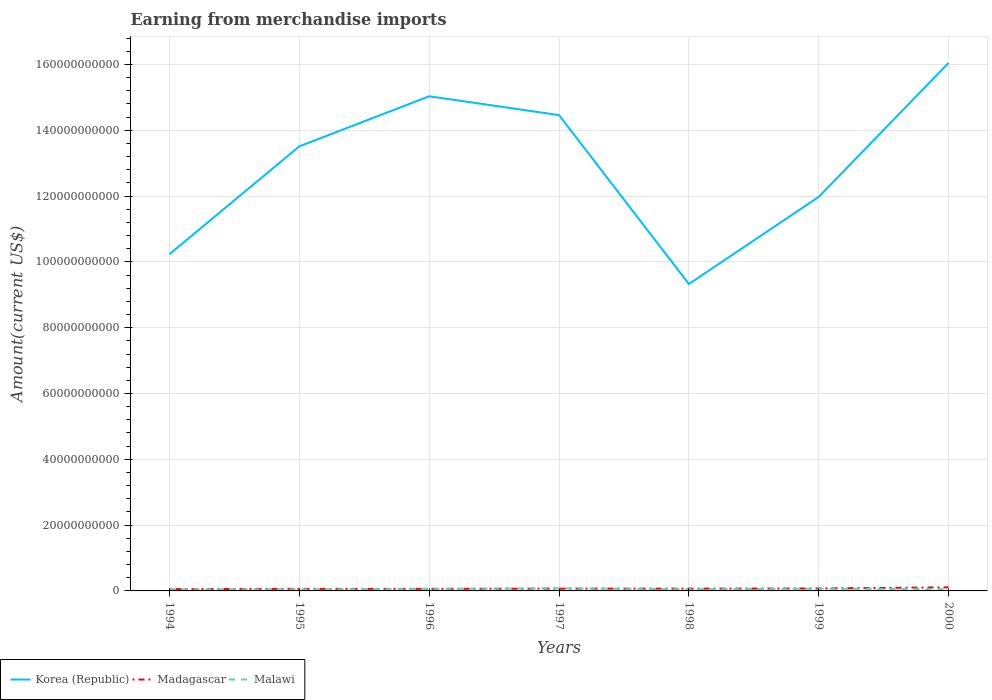How many different coloured lines are there?
Your answer should be very brief. 3. Is the number of lines equal to the number of legend labels?
Provide a short and direct response. Yes. Across all years, what is the maximum amount earned from merchandise imports in Madagascar?
Offer a terse response. 5.46e+08. What is the total amount earned from merchandise imports in Madagascar in the graph?
Offer a very short reply. -1.00e+06. What is the difference between the highest and the second highest amount earned from merchandise imports in Madagascar?
Make the answer very short. 5.51e+08. What is the difference between the highest and the lowest amount earned from merchandise imports in Madagascar?
Make the answer very short. 2. Is the amount earned from merchandise imports in Madagascar strictly greater than the amount earned from merchandise imports in Malawi over the years?
Your answer should be compact. No. How many lines are there?
Your response must be concise. 3. Are the values on the major ticks of Y-axis written in scientific E-notation?
Your answer should be compact. No. Does the graph contain any zero values?
Offer a very short reply. No. What is the title of the graph?
Make the answer very short. Earning from merchandise imports. What is the label or title of the X-axis?
Your answer should be compact. Years. What is the label or title of the Y-axis?
Give a very brief answer. Amount(current US$). What is the Amount(current US$) of Korea (Republic) in 1994?
Ensure brevity in your answer.  1.02e+11. What is the Amount(current US$) in Madagascar in 1994?
Make the answer very short. 5.46e+08. What is the Amount(current US$) of Malawi in 1994?
Your answer should be very brief. 4.97e+08. What is the Amount(current US$) of Korea (Republic) in 1995?
Offer a terse response. 1.35e+11. What is the Amount(current US$) in Madagascar in 1995?
Offer a terse response. 6.28e+08. What is the Amount(current US$) in Malawi in 1995?
Ensure brevity in your answer.  4.75e+08. What is the Amount(current US$) of Korea (Republic) in 1996?
Make the answer very short. 1.50e+11. What is the Amount(current US$) of Madagascar in 1996?
Offer a terse response. 6.29e+08. What is the Amount(current US$) of Malawi in 1996?
Your response must be concise. 6.24e+08. What is the Amount(current US$) of Korea (Republic) in 1997?
Offer a very short reply. 1.45e+11. What is the Amount(current US$) in Madagascar in 1997?
Offer a terse response. 6.94e+08. What is the Amount(current US$) of Malawi in 1997?
Keep it short and to the point. 7.81e+08. What is the Amount(current US$) of Korea (Republic) in 1998?
Your response must be concise. 9.33e+1. What is the Amount(current US$) in Madagascar in 1998?
Provide a succinct answer. 6.93e+08. What is the Amount(current US$) of Malawi in 1998?
Your response must be concise. 5.15e+08. What is the Amount(current US$) of Korea (Republic) in 1999?
Offer a terse response. 1.20e+11. What is the Amount(current US$) in Madagascar in 1999?
Your answer should be compact. 7.42e+08. What is the Amount(current US$) in Malawi in 1999?
Your answer should be very brief. 6.73e+08. What is the Amount(current US$) in Korea (Republic) in 2000?
Make the answer very short. 1.60e+11. What is the Amount(current US$) of Madagascar in 2000?
Your response must be concise. 1.10e+09. What is the Amount(current US$) in Malawi in 2000?
Offer a very short reply. 5.32e+08. Across all years, what is the maximum Amount(current US$) in Korea (Republic)?
Provide a succinct answer. 1.60e+11. Across all years, what is the maximum Amount(current US$) of Madagascar?
Provide a short and direct response. 1.10e+09. Across all years, what is the maximum Amount(current US$) of Malawi?
Make the answer very short. 7.81e+08. Across all years, what is the minimum Amount(current US$) of Korea (Republic)?
Offer a terse response. 9.33e+1. Across all years, what is the minimum Amount(current US$) of Madagascar?
Make the answer very short. 5.46e+08. Across all years, what is the minimum Amount(current US$) of Malawi?
Offer a very short reply. 4.75e+08. What is the total Amount(current US$) in Korea (Republic) in the graph?
Keep it short and to the point. 9.06e+11. What is the total Amount(current US$) in Madagascar in the graph?
Make the answer very short. 5.03e+09. What is the total Amount(current US$) in Malawi in the graph?
Your answer should be compact. 4.10e+09. What is the difference between the Amount(current US$) in Korea (Republic) in 1994 and that in 1995?
Offer a terse response. -3.28e+1. What is the difference between the Amount(current US$) in Madagascar in 1994 and that in 1995?
Provide a succinct answer. -8.20e+07. What is the difference between the Amount(current US$) in Malawi in 1994 and that in 1995?
Offer a terse response. 2.20e+07. What is the difference between the Amount(current US$) of Korea (Republic) in 1994 and that in 1996?
Offer a very short reply. -4.80e+1. What is the difference between the Amount(current US$) of Madagascar in 1994 and that in 1996?
Your answer should be very brief. -8.30e+07. What is the difference between the Amount(current US$) in Malawi in 1994 and that in 1996?
Ensure brevity in your answer.  -1.27e+08. What is the difference between the Amount(current US$) of Korea (Republic) in 1994 and that in 1997?
Your answer should be very brief. -4.23e+1. What is the difference between the Amount(current US$) of Madagascar in 1994 and that in 1997?
Provide a short and direct response. -1.48e+08. What is the difference between the Amount(current US$) in Malawi in 1994 and that in 1997?
Your response must be concise. -2.84e+08. What is the difference between the Amount(current US$) of Korea (Republic) in 1994 and that in 1998?
Offer a very short reply. 9.07e+09. What is the difference between the Amount(current US$) of Madagascar in 1994 and that in 1998?
Give a very brief answer. -1.47e+08. What is the difference between the Amount(current US$) of Malawi in 1994 and that in 1998?
Keep it short and to the point. -1.80e+07. What is the difference between the Amount(current US$) in Korea (Republic) in 1994 and that in 1999?
Offer a terse response. -1.74e+1. What is the difference between the Amount(current US$) in Madagascar in 1994 and that in 1999?
Give a very brief answer. -1.96e+08. What is the difference between the Amount(current US$) of Malawi in 1994 and that in 1999?
Provide a succinct answer. -1.76e+08. What is the difference between the Amount(current US$) in Korea (Republic) in 1994 and that in 2000?
Make the answer very short. -5.81e+1. What is the difference between the Amount(current US$) in Madagascar in 1994 and that in 2000?
Provide a succinct answer. -5.51e+08. What is the difference between the Amount(current US$) of Malawi in 1994 and that in 2000?
Make the answer very short. -3.50e+07. What is the difference between the Amount(current US$) in Korea (Republic) in 1995 and that in 1996?
Provide a succinct answer. -1.52e+1. What is the difference between the Amount(current US$) in Malawi in 1995 and that in 1996?
Offer a very short reply. -1.49e+08. What is the difference between the Amount(current US$) in Korea (Republic) in 1995 and that in 1997?
Give a very brief answer. -9.50e+09. What is the difference between the Amount(current US$) of Madagascar in 1995 and that in 1997?
Offer a very short reply. -6.60e+07. What is the difference between the Amount(current US$) in Malawi in 1995 and that in 1997?
Provide a succinct answer. -3.06e+08. What is the difference between the Amount(current US$) in Korea (Republic) in 1995 and that in 1998?
Provide a succinct answer. 4.18e+1. What is the difference between the Amount(current US$) in Madagascar in 1995 and that in 1998?
Make the answer very short. -6.50e+07. What is the difference between the Amount(current US$) of Malawi in 1995 and that in 1998?
Your answer should be very brief. -4.00e+07. What is the difference between the Amount(current US$) of Korea (Republic) in 1995 and that in 1999?
Keep it short and to the point. 1.54e+1. What is the difference between the Amount(current US$) of Madagascar in 1995 and that in 1999?
Provide a succinct answer. -1.14e+08. What is the difference between the Amount(current US$) in Malawi in 1995 and that in 1999?
Your answer should be compact. -1.98e+08. What is the difference between the Amount(current US$) of Korea (Republic) in 1995 and that in 2000?
Offer a terse response. -2.54e+1. What is the difference between the Amount(current US$) of Madagascar in 1995 and that in 2000?
Keep it short and to the point. -4.69e+08. What is the difference between the Amount(current US$) in Malawi in 1995 and that in 2000?
Make the answer very short. -5.70e+07. What is the difference between the Amount(current US$) in Korea (Republic) in 1996 and that in 1997?
Make the answer very short. 5.72e+09. What is the difference between the Amount(current US$) of Madagascar in 1996 and that in 1997?
Keep it short and to the point. -6.50e+07. What is the difference between the Amount(current US$) in Malawi in 1996 and that in 1997?
Your answer should be very brief. -1.57e+08. What is the difference between the Amount(current US$) of Korea (Republic) in 1996 and that in 1998?
Provide a short and direct response. 5.71e+1. What is the difference between the Amount(current US$) in Madagascar in 1996 and that in 1998?
Give a very brief answer. -6.40e+07. What is the difference between the Amount(current US$) in Malawi in 1996 and that in 1998?
Offer a terse response. 1.09e+08. What is the difference between the Amount(current US$) of Korea (Republic) in 1996 and that in 1999?
Your answer should be compact. 3.06e+1. What is the difference between the Amount(current US$) in Madagascar in 1996 and that in 1999?
Ensure brevity in your answer.  -1.13e+08. What is the difference between the Amount(current US$) of Malawi in 1996 and that in 1999?
Your response must be concise. -4.90e+07. What is the difference between the Amount(current US$) of Korea (Republic) in 1996 and that in 2000?
Ensure brevity in your answer.  -1.01e+1. What is the difference between the Amount(current US$) of Madagascar in 1996 and that in 2000?
Provide a succinct answer. -4.68e+08. What is the difference between the Amount(current US$) of Malawi in 1996 and that in 2000?
Your response must be concise. 9.20e+07. What is the difference between the Amount(current US$) in Korea (Republic) in 1997 and that in 1998?
Offer a very short reply. 5.13e+1. What is the difference between the Amount(current US$) of Madagascar in 1997 and that in 1998?
Make the answer very short. 1.00e+06. What is the difference between the Amount(current US$) in Malawi in 1997 and that in 1998?
Your answer should be compact. 2.66e+08. What is the difference between the Amount(current US$) of Korea (Republic) in 1997 and that in 1999?
Keep it short and to the point. 2.49e+1. What is the difference between the Amount(current US$) in Madagascar in 1997 and that in 1999?
Make the answer very short. -4.80e+07. What is the difference between the Amount(current US$) of Malawi in 1997 and that in 1999?
Your response must be concise. 1.08e+08. What is the difference between the Amount(current US$) in Korea (Republic) in 1997 and that in 2000?
Give a very brief answer. -1.59e+1. What is the difference between the Amount(current US$) in Madagascar in 1997 and that in 2000?
Provide a short and direct response. -4.03e+08. What is the difference between the Amount(current US$) in Malawi in 1997 and that in 2000?
Provide a succinct answer. 2.49e+08. What is the difference between the Amount(current US$) in Korea (Republic) in 1998 and that in 1999?
Give a very brief answer. -2.65e+1. What is the difference between the Amount(current US$) in Madagascar in 1998 and that in 1999?
Your answer should be very brief. -4.90e+07. What is the difference between the Amount(current US$) of Malawi in 1998 and that in 1999?
Make the answer very short. -1.58e+08. What is the difference between the Amount(current US$) of Korea (Republic) in 1998 and that in 2000?
Offer a very short reply. -6.72e+1. What is the difference between the Amount(current US$) of Madagascar in 1998 and that in 2000?
Offer a very short reply. -4.04e+08. What is the difference between the Amount(current US$) in Malawi in 1998 and that in 2000?
Provide a short and direct response. -1.70e+07. What is the difference between the Amount(current US$) in Korea (Republic) in 1999 and that in 2000?
Keep it short and to the point. -4.07e+1. What is the difference between the Amount(current US$) in Madagascar in 1999 and that in 2000?
Offer a terse response. -3.55e+08. What is the difference between the Amount(current US$) in Malawi in 1999 and that in 2000?
Provide a succinct answer. 1.41e+08. What is the difference between the Amount(current US$) in Korea (Republic) in 1994 and the Amount(current US$) in Madagascar in 1995?
Your answer should be compact. 1.02e+11. What is the difference between the Amount(current US$) of Korea (Republic) in 1994 and the Amount(current US$) of Malawi in 1995?
Provide a short and direct response. 1.02e+11. What is the difference between the Amount(current US$) of Madagascar in 1994 and the Amount(current US$) of Malawi in 1995?
Your answer should be compact. 7.10e+07. What is the difference between the Amount(current US$) of Korea (Republic) in 1994 and the Amount(current US$) of Madagascar in 1996?
Your answer should be compact. 1.02e+11. What is the difference between the Amount(current US$) in Korea (Republic) in 1994 and the Amount(current US$) in Malawi in 1996?
Give a very brief answer. 1.02e+11. What is the difference between the Amount(current US$) in Madagascar in 1994 and the Amount(current US$) in Malawi in 1996?
Keep it short and to the point. -7.80e+07. What is the difference between the Amount(current US$) in Korea (Republic) in 1994 and the Amount(current US$) in Madagascar in 1997?
Your response must be concise. 1.02e+11. What is the difference between the Amount(current US$) in Korea (Republic) in 1994 and the Amount(current US$) in Malawi in 1997?
Your response must be concise. 1.02e+11. What is the difference between the Amount(current US$) of Madagascar in 1994 and the Amount(current US$) of Malawi in 1997?
Keep it short and to the point. -2.35e+08. What is the difference between the Amount(current US$) of Korea (Republic) in 1994 and the Amount(current US$) of Madagascar in 1998?
Your answer should be very brief. 1.02e+11. What is the difference between the Amount(current US$) in Korea (Republic) in 1994 and the Amount(current US$) in Malawi in 1998?
Offer a terse response. 1.02e+11. What is the difference between the Amount(current US$) of Madagascar in 1994 and the Amount(current US$) of Malawi in 1998?
Make the answer very short. 3.10e+07. What is the difference between the Amount(current US$) in Korea (Republic) in 1994 and the Amount(current US$) in Madagascar in 1999?
Make the answer very short. 1.02e+11. What is the difference between the Amount(current US$) of Korea (Republic) in 1994 and the Amount(current US$) of Malawi in 1999?
Provide a short and direct response. 1.02e+11. What is the difference between the Amount(current US$) of Madagascar in 1994 and the Amount(current US$) of Malawi in 1999?
Provide a succinct answer. -1.27e+08. What is the difference between the Amount(current US$) in Korea (Republic) in 1994 and the Amount(current US$) in Madagascar in 2000?
Provide a succinct answer. 1.01e+11. What is the difference between the Amount(current US$) in Korea (Republic) in 1994 and the Amount(current US$) in Malawi in 2000?
Offer a very short reply. 1.02e+11. What is the difference between the Amount(current US$) of Madagascar in 1994 and the Amount(current US$) of Malawi in 2000?
Your answer should be compact. 1.40e+07. What is the difference between the Amount(current US$) of Korea (Republic) in 1995 and the Amount(current US$) of Madagascar in 1996?
Provide a short and direct response. 1.34e+11. What is the difference between the Amount(current US$) in Korea (Republic) in 1995 and the Amount(current US$) in Malawi in 1996?
Your response must be concise. 1.34e+11. What is the difference between the Amount(current US$) in Madagascar in 1995 and the Amount(current US$) in Malawi in 1996?
Provide a succinct answer. 4.00e+06. What is the difference between the Amount(current US$) of Korea (Republic) in 1995 and the Amount(current US$) of Madagascar in 1997?
Keep it short and to the point. 1.34e+11. What is the difference between the Amount(current US$) in Korea (Republic) in 1995 and the Amount(current US$) in Malawi in 1997?
Make the answer very short. 1.34e+11. What is the difference between the Amount(current US$) of Madagascar in 1995 and the Amount(current US$) of Malawi in 1997?
Your response must be concise. -1.53e+08. What is the difference between the Amount(current US$) in Korea (Republic) in 1995 and the Amount(current US$) in Madagascar in 1998?
Your answer should be very brief. 1.34e+11. What is the difference between the Amount(current US$) in Korea (Republic) in 1995 and the Amount(current US$) in Malawi in 1998?
Your response must be concise. 1.35e+11. What is the difference between the Amount(current US$) in Madagascar in 1995 and the Amount(current US$) in Malawi in 1998?
Provide a succinct answer. 1.13e+08. What is the difference between the Amount(current US$) of Korea (Republic) in 1995 and the Amount(current US$) of Madagascar in 1999?
Provide a succinct answer. 1.34e+11. What is the difference between the Amount(current US$) in Korea (Republic) in 1995 and the Amount(current US$) in Malawi in 1999?
Offer a terse response. 1.34e+11. What is the difference between the Amount(current US$) of Madagascar in 1995 and the Amount(current US$) of Malawi in 1999?
Offer a terse response. -4.50e+07. What is the difference between the Amount(current US$) in Korea (Republic) in 1995 and the Amount(current US$) in Madagascar in 2000?
Your answer should be very brief. 1.34e+11. What is the difference between the Amount(current US$) of Korea (Republic) in 1995 and the Amount(current US$) of Malawi in 2000?
Ensure brevity in your answer.  1.35e+11. What is the difference between the Amount(current US$) of Madagascar in 1995 and the Amount(current US$) of Malawi in 2000?
Provide a short and direct response. 9.60e+07. What is the difference between the Amount(current US$) in Korea (Republic) in 1996 and the Amount(current US$) in Madagascar in 1997?
Ensure brevity in your answer.  1.50e+11. What is the difference between the Amount(current US$) of Korea (Republic) in 1996 and the Amount(current US$) of Malawi in 1997?
Offer a terse response. 1.50e+11. What is the difference between the Amount(current US$) of Madagascar in 1996 and the Amount(current US$) of Malawi in 1997?
Ensure brevity in your answer.  -1.52e+08. What is the difference between the Amount(current US$) in Korea (Republic) in 1996 and the Amount(current US$) in Madagascar in 1998?
Provide a succinct answer. 1.50e+11. What is the difference between the Amount(current US$) in Korea (Republic) in 1996 and the Amount(current US$) in Malawi in 1998?
Ensure brevity in your answer.  1.50e+11. What is the difference between the Amount(current US$) in Madagascar in 1996 and the Amount(current US$) in Malawi in 1998?
Keep it short and to the point. 1.14e+08. What is the difference between the Amount(current US$) of Korea (Republic) in 1996 and the Amount(current US$) of Madagascar in 1999?
Your answer should be very brief. 1.50e+11. What is the difference between the Amount(current US$) in Korea (Republic) in 1996 and the Amount(current US$) in Malawi in 1999?
Provide a succinct answer. 1.50e+11. What is the difference between the Amount(current US$) in Madagascar in 1996 and the Amount(current US$) in Malawi in 1999?
Give a very brief answer. -4.40e+07. What is the difference between the Amount(current US$) in Korea (Republic) in 1996 and the Amount(current US$) in Madagascar in 2000?
Your answer should be very brief. 1.49e+11. What is the difference between the Amount(current US$) of Korea (Republic) in 1996 and the Amount(current US$) of Malawi in 2000?
Make the answer very short. 1.50e+11. What is the difference between the Amount(current US$) in Madagascar in 1996 and the Amount(current US$) in Malawi in 2000?
Provide a succinct answer. 9.70e+07. What is the difference between the Amount(current US$) in Korea (Republic) in 1997 and the Amount(current US$) in Madagascar in 1998?
Make the answer very short. 1.44e+11. What is the difference between the Amount(current US$) in Korea (Republic) in 1997 and the Amount(current US$) in Malawi in 1998?
Keep it short and to the point. 1.44e+11. What is the difference between the Amount(current US$) of Madagascar in 1997 and the Amount(current US$) of Malawi in 1998?
Your answer should be very brief. 1.79e+08. What is the difference between the Amount(current US$) in Korea (Republic) in 1997 and the Amount(current US$) in Madagascar in 1999?
Provide a short and direct response. 1.44e+11. What is the difference between the Amount(current US$) in Korea (Republic) in 1997 and the Amount(current US$) in Malawi in 1999?
Provide a succinct answer. 1.44e+11. What is the difference between the Amount(current US$) in Madagascar in 1997 and the Amount(current US$) in Malawi in 1999?
Offer a terse response. 2.10e+07. What is the difference between the Amount(current US$) in Korea (Republic) in 1997 and the Amount(current US$) in Madagascar in 2000?
Keep it short and to the point. 1.44e+11. What is the difference between the Amount(current US$) of Korea (Republic) in 1997 and the Amount(current US$) of Malawi in 2000?
Ensure brevity in your answer.  1.44e+11. What is the difference between the Amount(current US$) in Madagascar in 1997 and the Amount(current US$) in Malawi in 2000?
Keep it short and to the point. 1.62e+08. What is the difference between the Amount(current US$) of Korea (Republic) in 1998 and the Amount(current US$) of Madagascar in 1999?
Ensure brevity in your answer.  9.25e+1. What is the difference between the Amount(current US$) in Korea (Republic) in 1998 and the Amount(current US$) in Malawi in 1999?
Your answer should be compact. 9.26e+1. What is the difference between the Amount(current US$) of Korea (Republic) in 1998 and the Amount(current US$) of Madagascar in 2000?
Your answer should be very brief. 9.22e+1. What is the difference between the Amount(current US$) in Korea (Republic) in 1998 and the Amount(current US$) in Malawi in 2000?
Make the answer very short. 9.28e+1. What is the difference between the Amount(current US$) in Madagascar in 1998 and the Amount(current US$) in Malawi in 2000?
Provide a succinct answer. 1.61e+08. What is the difference between the Amount(current US$) of Korea (Republic) in 1999 and the Amount(current US$) of Madagascar in 2000?
Provide a succinct answer. 1.19e+11. What is the difference between the Amount(current US$) in Korea (Republic) in 1999 and the Amount(current US$) in Malawi in 2000?
Your answer should be compact. 1.19e+11. What is the difference between the Amount(current US$) in Madagascar in 1999 and the Amount(current US$) in Malawi in 2000?
Ensure brevity in your answer.  2.10e+08. What is the average Amount(current US$) of Korea (Republic) per year?
Offer a terse response. 1.29e+11. What is the average Amount(current US$) in Madagascar per year?
Make the answer very short. 7.18e+08. What is the average Amount(current US$) in Malawi per year?
Offer a very short reply. 5.85e+08. In the year 1994, what is the difference between the Amount(current US$) of Korea (Republic) and Amount(current US$) of Madagascar?
Provide a succinct answer. 1.02e+11. In the year 1994, what is the difference between the Amount(current US$) in Korea (Republic) and Amount(current US$) in Malawi?
Make the answer very short. 1.02e+11. In the year 1994, what is the difference between the Amount(current US$) of Madagascar and Amount(current US$) of Malawi?
Offer a terse response. 4.90e+07. In the year 1995, what is the difference between the Amount(current US$) of Korea (Republic) and Amount(current US$) of Madagascar?
Your answer should be very brief. 1.34e+11. In the year 1995, what is the difference between the Amount(current US$) of Korea (Republic) and Amount(current US$) of Malawi?
Your answer should be compact. 1.35e+11. In the year 1995, what is the difference between the Amount(current US$) in Madagascar and Amount(current US$) in Malawi?
Provide a short and direct response. 1.53e+08. In the year 1996, what is the difference between the Amount(current US$) in Korea (Republic) and Amount(current US$) in Madagascar?
Your answer should be very brief. 1.50e+11. In the year 1996, what is the difference between the Amount(current US$) in Korea (Republic) and Amount(current US$) in Malawi?
Your response must be concise. 1.50e+11. In the year 1996, what is the difference between the Amount(current US$) of Madagascar and Amount(current US$) of Malawi?
Offer a terse response. 5.00e+06. In the year 1997, what is the difference between the Amount(current US$) in Korea (Republic) and Amount(current US$) in Madagascar?
Your response must be concise. 1.44e+11. In the year 1997, what is the difference between the Amount(current US$) of Korea (Republic) and Amount(current US$) of Malawi?
Keep it short and to the point. 1.44e+11. In the year 1997, what is the difference between the Amount(current US$) in Madagascar and Amount(current US$) in Malawi?
Give a very brief answer. -8.70e+07. In the year 1998, what is the difference between the Amount(current US$) of Korea (Republic) and Amount(current US$) of Madagascar?
Provide a succinct answer. 9.26e+1. In the year 1998, what is the difference between the Amount(current US$) in Korea (Republic) and Amount(current US$) in Malawi?
Provide a short and direct response. 9.28e+1. In the year 1998, what is the difference between the Amount(current US$) in Madagascar and Amount(current US$) in Malawi?
Ensure brevity in your answer.  1.78e+08. In the year 1999, what is the difference between the Amount(current US$) of Korea (Republic) and Amount(current US$) of Madagascar?
Your response must be concise. 1.19e+11. In the year 1999, what is the difference between the Amount(current US$) of Korea (Republic) and Amount(current US$) of Malawi?
Your response must be concise. 1.19e+11. In the year 1999, what is the difference between the Amount(current US$) of Madagascar and Amount(current US$) of Malawi?
Make the answer very short. 6.90e+07. In the year 2000, what is the difference between the Amount(current US$) of Korea (Republic) and Amount(current US$) of Madagascar?
Offer a very short reply. 1.59e+11. In the year 2000, what is the difference between the Amount(current US$) in Korea (Republic) and Amount(current US$) in Malawi?
Offer a terse response. 1.60e+11. In the year 2000, what is the difference between the Amount(current US$) of Madagascar and Amount(current US$) of Malawi?
Provide a succinct answer. 5.65e+08. What is the ratio of the Amount(current US$) of Korea (Republic) in 1994 to that in 1995?
Your response must be concise. 0.76. What is the ratio of the Amount(current US$) in Madagascar in 1994 to that in 1995?
Offer a very short reply. 0.87. What is the ratio of the Amount(current US$) of Malawi in 1994 to that in 1995?
Offer a very short reply. 1.05. What is the ratio of the Amount(current US$) in Korea (Republic) in 1994 to that in 1996?
Your answer should be compact. 0.68. What is the ratio of the Amount(current US$) of Madagascar in 1994 to that in 1996?
Your answer should be compact. 0.87. What is the ratio of the Amount(current US$) in Malawi in 1994 to that in 1996?
Ensure brevity in your answer.  0.8. What is the ratio of the Amount(current US$) in Korea (Republic) in 1994 to that in 1997?
Provide a succinct answer. 0.71. What is the ratio of the Amount(current US$) in Madagascar in 1994 to that in 1997?
Your answer should be compact. 0.79. What is the ratio of the Amount(current US$) of Malawi in 1994 to that in 1997?
Your answer should be compact. 0.64. What is the ratio of the Amount(current US$) in Korea (Republic) in 1994 to that in 1998?
Your answer should be very brief. 1.1. What is the ratio of the Amount(current US$) of Madagascar in 1994 to that in 1998?
Your answer should be very brief. 0.79. What is the ratio of the Amount(current US$) in Korea (Republic) in 1994 to that in 1999?
Give a very brief answer. 0.85. What is the ratio of the Amount(current US$) of Madagascar in 1994 to that in 1999?
Ensure brevity in your answer.  0.74. What is the ratio of the Amount(current US$) of Malawi in 1994 to that in 1999?
Offer a terse response. 0.74. What is the ratio of the Amount(current US$) in Korea (Republic) in 1994 to that in 2000?
Your response must be concise. 0.64. What is the ratio of the Amount(current US$) in Madagascar in 1994 to that in 2000?
Your answer should be compact. 0.5. What is the ratio of the Amount(current US$) of Malawi in 1994 to that in 2000?
Your response must be concise. 0.93. What is the ratio of the Amount(current US$) of Korea (Republic) in 1995 to that in 1996?
Give a very brief answer. 0.9. What is the ratio of the Amount(current US$) of Madagascar in 1995 to that in 1996?
Provide a succinct answer. 1. What is the ratio of the Amount(current US$) of Malawi in 1995 to that in 1996?
Provide a short and direct response. 0.76. What is the ratio of the Amount(current US$) of Korea (Republic) in 1995 to that in 1997?
Ensure brevity in your answer.  0.93. What is the ratio of the Amount(current US$) in Madagascar in 1995 to that in 1997?
Keep it short and to the point. 0.9. What is the ratio of the Amount(current US$) of Malawi in 1995 to that in 1997?
Your answer should be compact. 0.61. What is the ratio of the Amount(current US$) of Korea (Republic) in 1995 to that in 1998?
Your response must be concise. 1.45. What is the ratio of the Amount(current US$) in Madagascar in 1995 to that in 1998?
Your answer should be compact. 0.91. What is the ratio of the Amount(current US$) of Malawi in 1995 to that in 1998?
Ensure brevity in your answer.  0.92. What is the ratio of the Amount(current US$) in Korea (Republic) in 1995 to that in 1999?
Keep it short and to the point. 1.13. What is the ratio of the Amount(current US$) of Madagascar in 1995 to that in 1999?
Ensure brevity in your answer.  0.85. What is the ratio of the Amount(current US$) in Malawi in 1995 to that in 1999?
Your answer should be compact. 0.71. What is the ratio of the Amount(current US$) in Korea (Republic) in 1995 to that in 2000?
Offer a very short reply. 0.84. What is the ratio of the Amount(current US$) of Madagascar in 1995 to that in 2000?
Your answer should be compact. 0.57. What is the ratio of the Amount(current US$) in Malawi in 1995 to that in 2000?
Keep it short and to the point. 0.89. What is the ratio of the Amount(current US$) in Korea (Republic) in 1996 to that in 1997?
Keep it short and to the point. 1.04. What is the ratio of the Amount(current US$) in Madagascar in 1996 to that in 1997?
Provide a short and direct response. 0.91. What is the ratio of the Amount(current US$) in Malawi in 1996 to that in 1997?
Your answer should be compact. 0.8. What is the ratio of the Amount(current US$) in Korea (Republic) in 1996 to that in 1998?
Make the answer very short. 1.61. What is the ratio of the Amount(current US$) in Madagascar in 1996 to that in 1998?
Offer a terse response. 0.91. What is the ratio of the Amount(current US$) in Malawi in 1996 to that in 1998?
Your answer should be very brief. 1.21. What is the ratio of the Amount(current US$) in Korea (Republic) in 1996 to that in 1999?
Keep it short and to the point. 1.26. What is the ratio of the Amount(current US$) in Madagascar in 1996 to that in 1999?
Provide a short and direct response. 0.85. What is the ratio of the Amount(current US$) in Malawi in 1996 to that in 1999?
Give a very brief answer. 0.93. What is the ratio of the Amount(current US$) of Korea (Republic) in 1996 to that in 2000?
Keep it short and to the point. 0.94. What is the ratio of the Amount(current US$) of Madagascar in 1996 to that in 2000?
Your answer should be compact. 0.57. What is the ratio of the Amount(current US$) of Malawi in 1996 to that in 2000?
Your response must be concise. 1.17. What is the ratio of the Amount(current US$) of Korea (Republic) in 1997 to that in 1998?
Provide a short and direct response. 1.55. What is the ratio of the Amount(current US$) in Madagascar in 1997 to that in 1998?
Ensure brevity in your answer.  1. What is the ratio of the Amount(current US$) of Malawi in 1997 to that in 1998?
Provide a succinct answer. 1.52. What is the ratio of the Amount(current US$) in Korea (Republic) in 1997 to that in 1999?
Ensure brevity in your answer.  1.21. What is the ratio of the Amount(current US$) of Madagascar in 1997 to that in 1999?
Ensure brevity in your answer.  0.94. What is the ratio of the Amount(current US$) in Malawi in 1997 to that in 1999?
Ensure brevity in your answer.  1.16. What is the ratio of the Amount(current US$) of Korea (Republic) in 1997 to that in 2000?
Offer a very short reply. 0.9. What is the ratio of the Amount(current US$) of Madagascar in 1997 to that in 2000?
Your answer should be compact. 0.63. What is the ratio of the Amount(current US$) of Malawi in 1997 to that in 2000?
Provide a succinct answer. 1.47. What is the ratio of the Amount(current US$) of Korea (Republic) in 1998 to that in 1999?
Your answer should be compact. 0.78. What is the ratio of the Amount(current US$) of Madagascar in 1998 to that in 1999?
Your response must be concise. 0.93. What is the ratio of the Amount(current US$) in Malawi in 1998 to that in 1999?
Provide a short and direct response. 0.77. What is the ratio of the Amount(current US$) in Korea (Republic) in 1998 to that in 2000?
Ensure brevity in your answer.  0.58. What is the ratio of the Amount(current US$) in Madagascar in 1998 to that in 2000?
Provide a short and direct response. 0.63. What is the ratio of the Amount(current US$) in Korea (Republic) in 1999 to that in 2000?
Give a very brief answer. 0.75. What is the ratio of the Amount(current US$) in Madagascar in 1999 to that in 2000?
Your answer should be compact. 0.68. What is the ratio of the Amount(current US$) of Malawi in 1999 to that in 2000?
Your answer should be very brief. 1.26. What is the difference between the highest and the second highest Amount(current US$) of Korea (Republic)?
Ensure brevity in your answer.  1.01e+1. What is the difference between the highest and the second highest Amount(current US$) in Madagascar?
Give a very brief answer. 3.55e+08. What is the difference between the highest and the second highest Amount(current US$) in Malawi?
Make the answer very short. 1.08e+08. What is the difference between the highest and the lowest Amount(current US$) in Korea (Republic)?
Offer a terse response. 6.72e+1. What is the difference between the highest and the lowest Amount(current US$) of Madagascar?
Give a very brief answer. 5.51e+08. What is the difference between the highest and the lowest Amount(current US$) in Malawi?
Ensure brevity in your answer.  3.06e+08. 